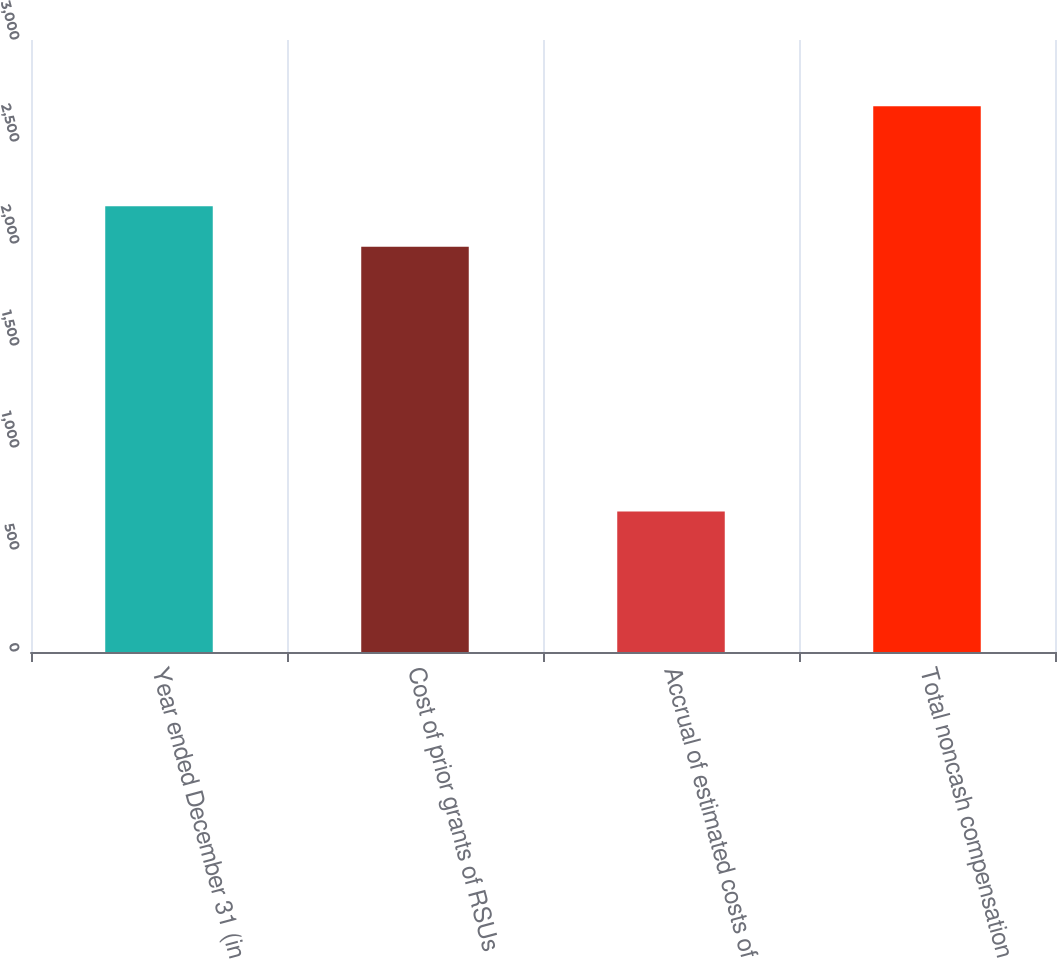<chart> <loc_0><loc_0><loc_500><loc_500><bar_chart><fcel>Year ended December 31 (in<fcel>Cost of prior grants of RSUs<fcel>Accrual of estimated costs of<fcel>Total noncash compensation<nl><fcel>2184.6<fcel>1986<fcel>689<fcel>2675<nl></chart> 